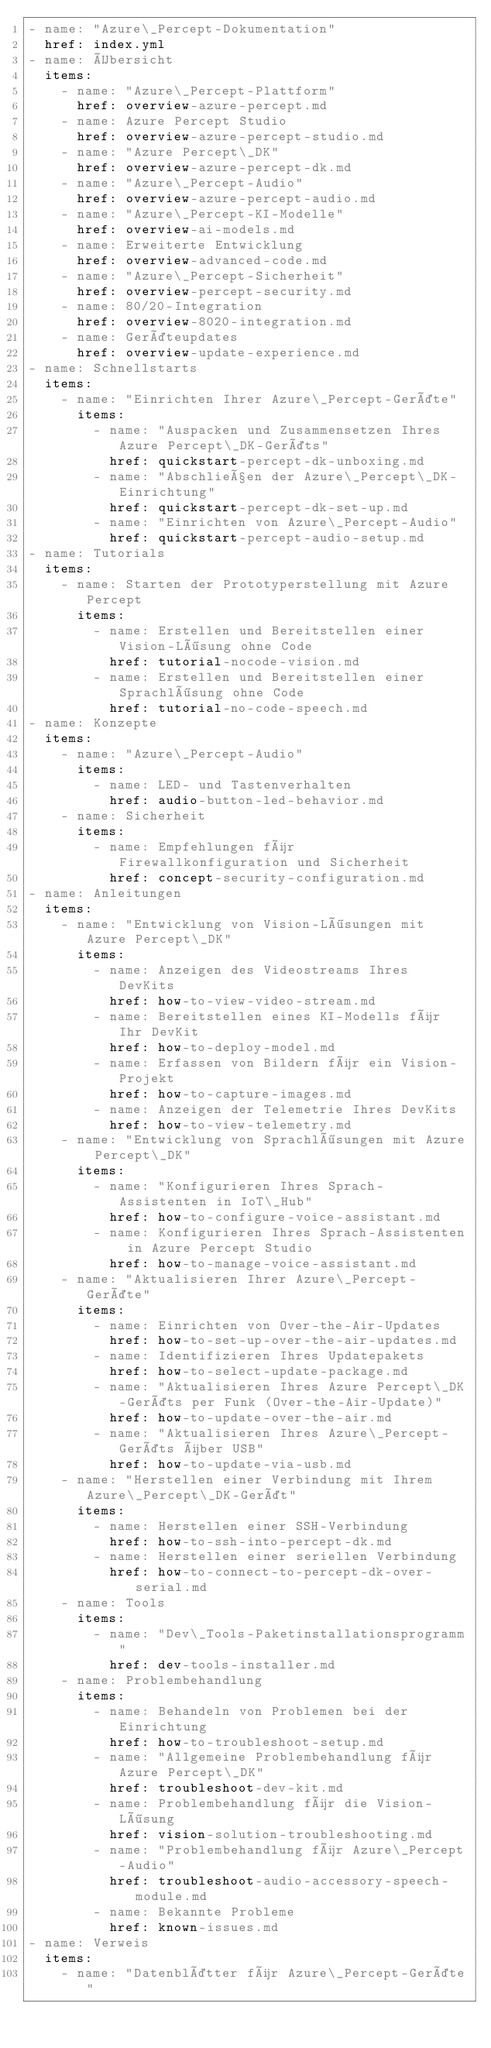<code> <loc_0><loc_0><loc_500><loc_500><_YAML_>- name: "Azure\_Percept-Dokumentation"
  href: index.yml
- name: Übersicht
  items:
    - name: "Azure\_Percept-Plattform"
      href: overview-azure-percept.md
    - name: Azure Percept Studio
      href: overview-azure-percept-studio.md
    - name: "Azure Percept\_DK"
      href: overview-azure-percept-dk.md
    - name: "Azure\_Percept-Audio"
      href: overview-azure-percept-audio.md
    - name: "Azure\_Percept-KI-Modelle"
      href: overview-ai-models.md
    - name: Erweiterte Entwicklung
      href: overview-advanced-code.md
    - name: "Azure\_Percept-Sicherheit"
      href: overview-percept-security.md
    - name: 80/20-Integration
      href: overview-8020-integration.md
    - name: Geräteupdates
      href: overview-update-experience.md
- name: Schnellstarts
  items:
    - name: "Einrichten Ihrer Azure\_Percept-Geräte"
      items:
        - name: "Auspacken und Zusammensetzen Ihres Azure Percept\_DK-Geräts"
          href: quickstart-percept-dk-unboxing.md
        - name: "Abschließen der Azure\_Percept\_DK-Einrichtung"
          href: quickstart-percept-dk-set-up.md
        - name: "Einrichten von Azure\_Percept-Audio"
          href: quickstart-percept-audio-setup.md
- name: Tutorials
  items:
    - name: Starten der Prototyperstellung mit Azure Percept
      items:
        - name: Erstellen und Bereitstellen einer Vision-Lösung ohne Code
          href: tutorial-nocode-vision.md
        - name: Erstellen und Bereitstellen einer Sprachlösung ohne Code
          href: tutorial-no-code-speech.md
- name: Konzepte
  items:
    - name: "Azure\_Percept-Audio"
      items:
        - name: LED- und Tastenverhalten
          href: audio-button-led-behavior.md
    - name: Sicherheit
      items:
        - name: Empfehlungen für Firewallkonfiguration und Sicherheit
          href: concept-security-configuration.md
- name: Anleitungen
  items:
    - name: "Entwicklung von Vision-Lösungen mit Azure Percept\_DK"
      items:
        - name: Anzeigen des Videostreams Ihres DevKits
          href: how-to-view-video-stream.md
        - name: Bereitstellen eines KI-Modells für Ihr DevKit
          href: how-to-deploy-model.md
        - name: Erfassen von Bildern für ein Vision-Projekt
          href: how-to-capture-images.md
        - name: Anzeigen der Telemetrie Ihres DevKits
          href: how-to-view-telemetry.md
    - name: "Entwicklung von Sprachlösungen mit Azure Percept\_DK"
      items:
        - name: "Konfigurieren Ihres Sprach-Assistenten in IoT\_Hub"
          href: how-to-configure-voice-assistant.md
        - name: Konfigurieren Ihres Sprach-Assistenten in Azure Percept Studio
          href: how-to-manage-voice-assistant.md
    - name: "Aktualisieren Ihrer Azure\_Percept-Geräte"
      items:
        - name: Einrichten von Over-the-Air-Updates
          href: how-to-set-up-over-the-air-updates.md
        - name: Identifizieren Ihres Updatepakets
          href: how-to-select-update-package.md
        - name: "Aktualisieren Ihres Azure Percept\_DK-Geräts per Funk (Over-the-Air-Update)"
          href: how-to-update-over-the-air.md
        - name: "Aktualisieren Ihres Azure\_Percept-Geräts über USB"
          href: how-to-update-via-usb.md
    - name: "Herstellen einer Verbindung mit Ihrem Azure\_Percept\_DK-Gerät"
      items:
        - name: Herstellen einer SSH-Verbindung
          href: how-to-ssh-into-percept-dk.md
        - name: Herstellen einer seriellen Verbindung
          href: how-to-connect-to-percept-dk-over-serial.md
    - name: Tools
      items:
        - name: "Dev\_Tools-Paketinstallationsprogramm"
          href: dev-tools-installer.md
    - name: Problembehandlung
      items:
        - name: Behandeln von Problemen bei der Einrichtung
          href: how-to-troubleshoot-setup.md
        - name: "Allgemeine Problembehandlung für Azure Percept\_DK"
          href: troubleshoot-dev-kit.md
        - name: Problembehandlung für die Vision-Lösung
          href: vision-solution-troubleshooting.md
        - name: "Problembehandlung für Azure\_Percept-Audio"
          href: troubleshoot-audio-accessory-speech-module.md
        - name: Bekannte Probleme
          href: known-issues.md
- name: Verweis
  items:
    - name: "Datenblätter für Azure\_Percept-Geräte"</code> 